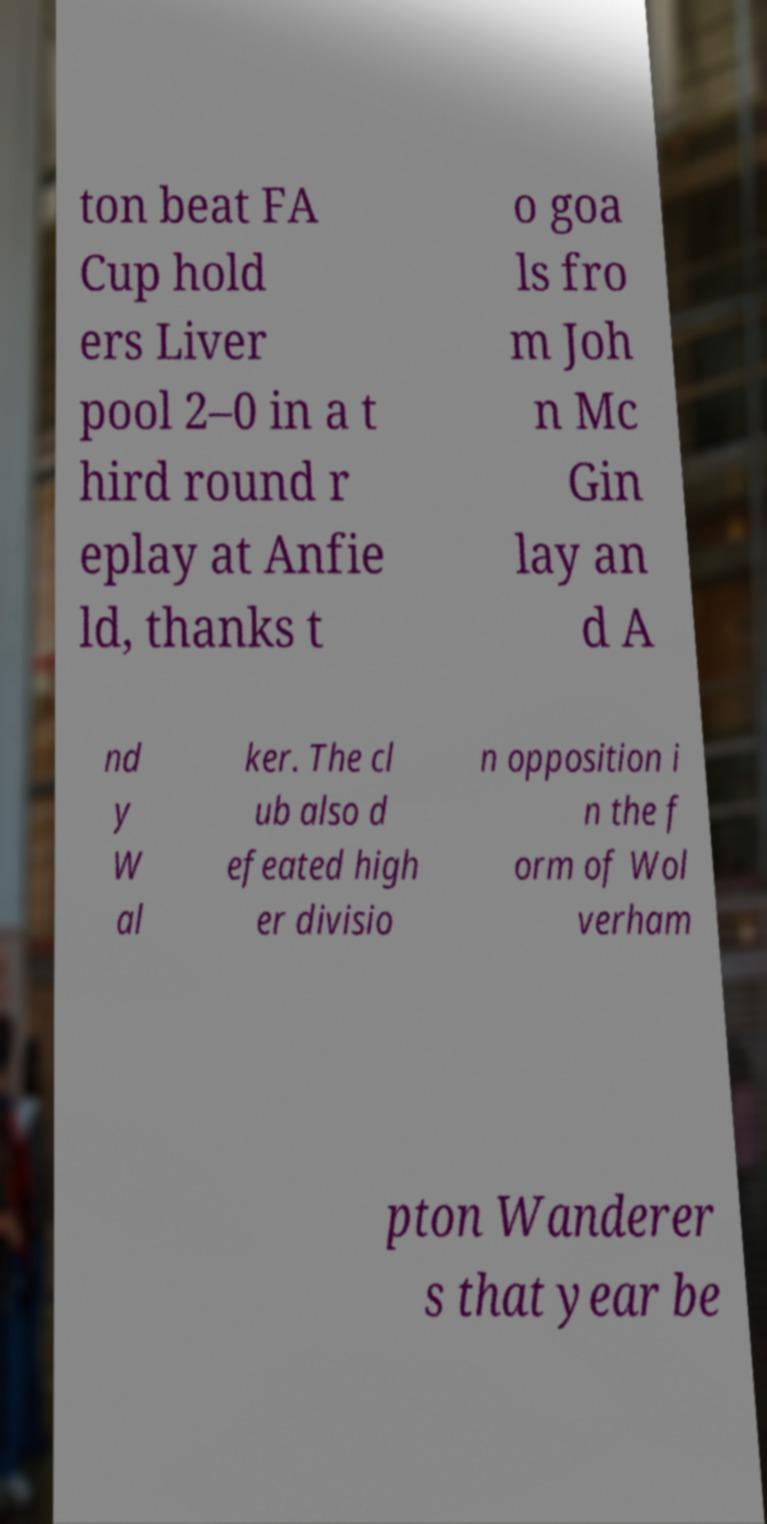Could you assist in decoding the text presented in this image and type it out clearly? ton beat FA Cup hold ers Liver pool 2–0 in a t hird round r eplay at Anfie ld, thanks t o goa ls fro m Joh n Mc Gin lay an d A nd y W al ker. The cl ub also d efeated high er divisio n opposition i n the f orm of Wol verham pton Wanderer s that year be 